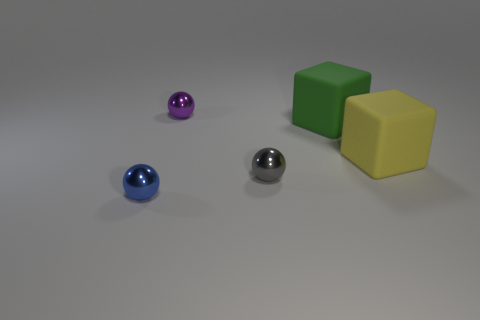Subtract all purple metallic balls. How many balls are left? 2 Subtract all blue balls. How many balls are left? 2 Subtract 2 spheres. How many spheres are left? 1 Add 2 tiny purple spheres. How many objects exist? 7 Subtract all yellow cylinders. How many green blocks are left? 1 Add 1 big green rubber cubes. How many big green rubber cubes exist? 2 Subtract 0 green spheres. How many objects are left? 5 Subtract all cubes. How many objects are left? 3 Subtract all blue cubes. Subtract all green balls. How many cubes are left? 2 Subtract all rubber objects. Subtract all small spheres. How many objects are left? 0 